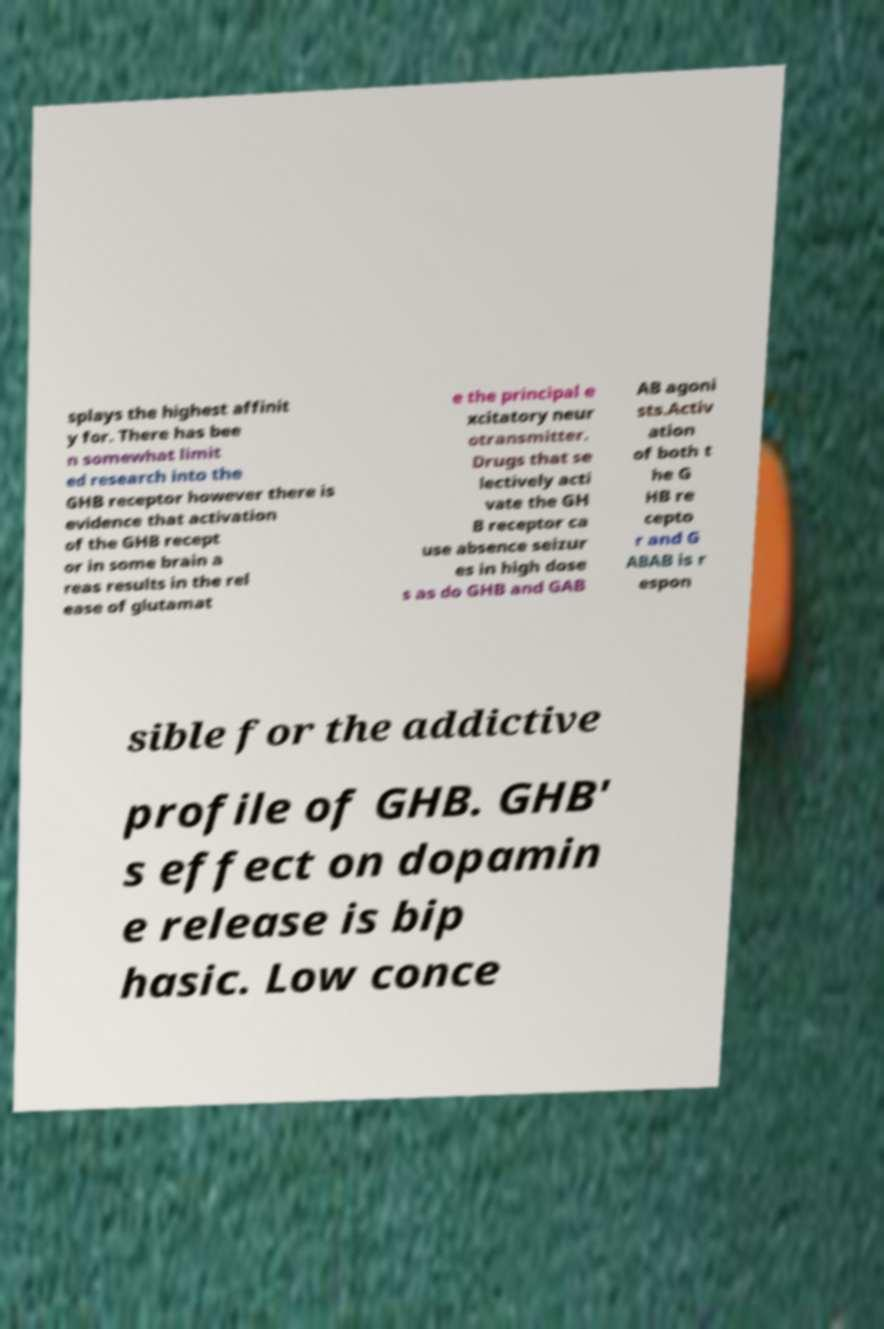Please identify and transcribe the text found in this image. splays the highest affinit y for. There has bee n somewhat limit ed research into the GHB receptor however there is evidence that activation of the GHB recept or in some brain a reas results in the rel ease of glutamat e the principal e xcitatory neur otransmitter. Drugs that se lectively acti vate the GH B receptor ca use absence seizur es in high dose s as do GHB and GAB AB agoni sts.Activ ation of both t he G HB re cepto r and G ABAB is r espon sible for the addictive profile of GHB. GHB' s effect on dopamin e release is bip hasic. Low conce 